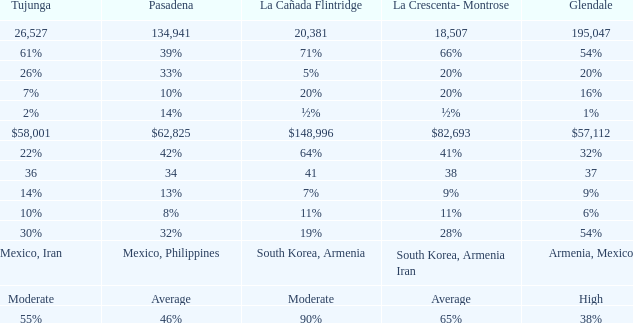What is the percentage of Tujunja when Pasadena is 33%? 26%. 